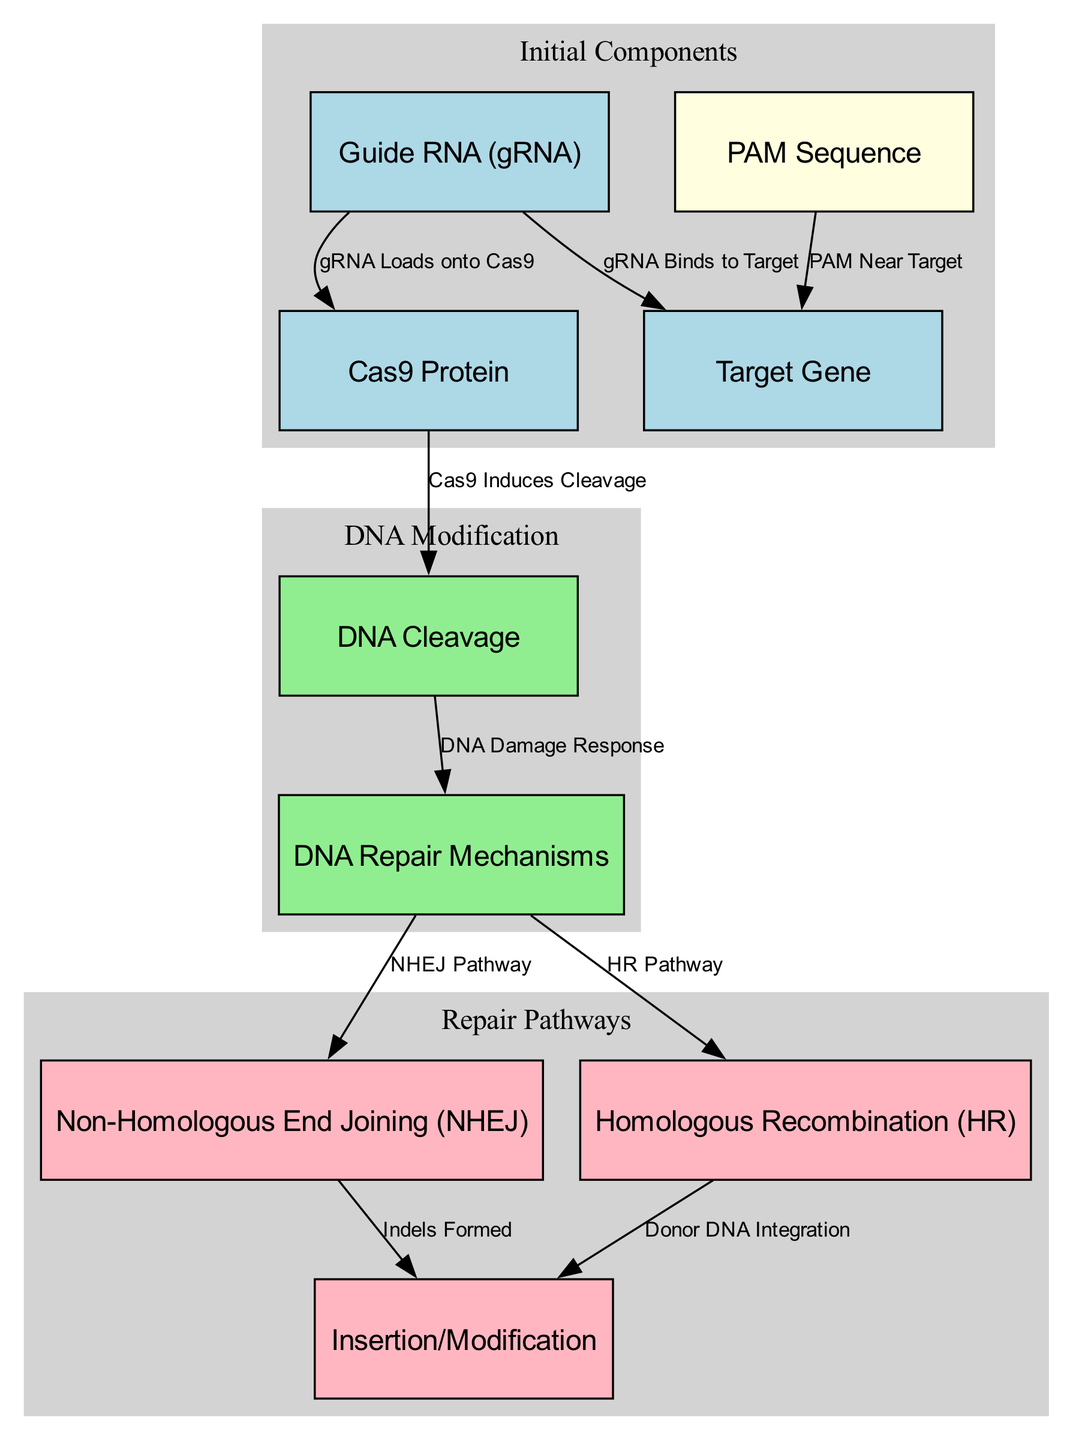What is the first component that binds to the target gene? The diagram indicates that the Guide RNA (gRNA) is the first component that binds to the target gene, as shown by the edge connecting the Guide RNA to the Target Gene labeled "gRNA Binds to Target".
Answer: Guide RNA How many repair pathways are shown in the diagram? The diagram illustrates two distinct repair pathways branching from the DNA Damage Response node: Non-Homologous End Joining (NHEJ) and Homologous Recombination (HR). Therefore, by counting these pathways, we see that there are two repair pathways depicted.
Answer: 2 What initiates DNA cleavage according to the diagram? The diagram specifies that the Cas9 protein induces cleavage of DNA, as shown by the edge labeled "Cas9 Induces Cleavage" leading from Cas9 to DNA Cleavage.
Answer: Cas9 Protein What is the outcome of the NHEJ pathway? The diagram indicates that the Non-Homologous End Joining (NHEJ) pathway leads to the formation of indels, as depicted by the edge connecting NHEJ to the Insertion/Modification node labeled "Indels Formed".
Answer: Indels Formed What needs to be present near the target gene for CRISPR-Cas9 to function? According to the diagram, a PAM Sequence must be present near the target gene, as indicated by the edge connecting the PAM Sequence to the Target Gene labeled "PAM Near Target".
Answer: PAM Sequence How does the donor DNA integrate into the genome? The diagram shows that donor DNA integration occurs through the Homologous Recombination (HR) pathway. This is illustrated by the edge connecting the HR node to the Insertion/Modification node labeled "Donor DNA Integration".
Answer: Donor DNA Integration What sequence of components leads to DNA cleavage? To reach DNA cleavage, the order is: Guide RNA binds to the Target Gene, the guide RNA loads onto the Cas9 Protein, and then the Cas9 induces cleavage, thus the complete sequence is: Guide RNA → Cas9 → DNA Cleavage.
Answer: Guide RNA, Cas9, DNA Cleavage What are the two functions of the DNA Repair Mechanisms depicted? The diagram shows two functions for the DNA Repair Mechanisms: it can activate the Non-Homologous End Joining pathway or the Homologous Recombination pathway, as evidenced by the edges leading to both NHEJ and HR labeled "NHEJ Pathway" and "HR Pathway".
Answer: NHEJ and HR 